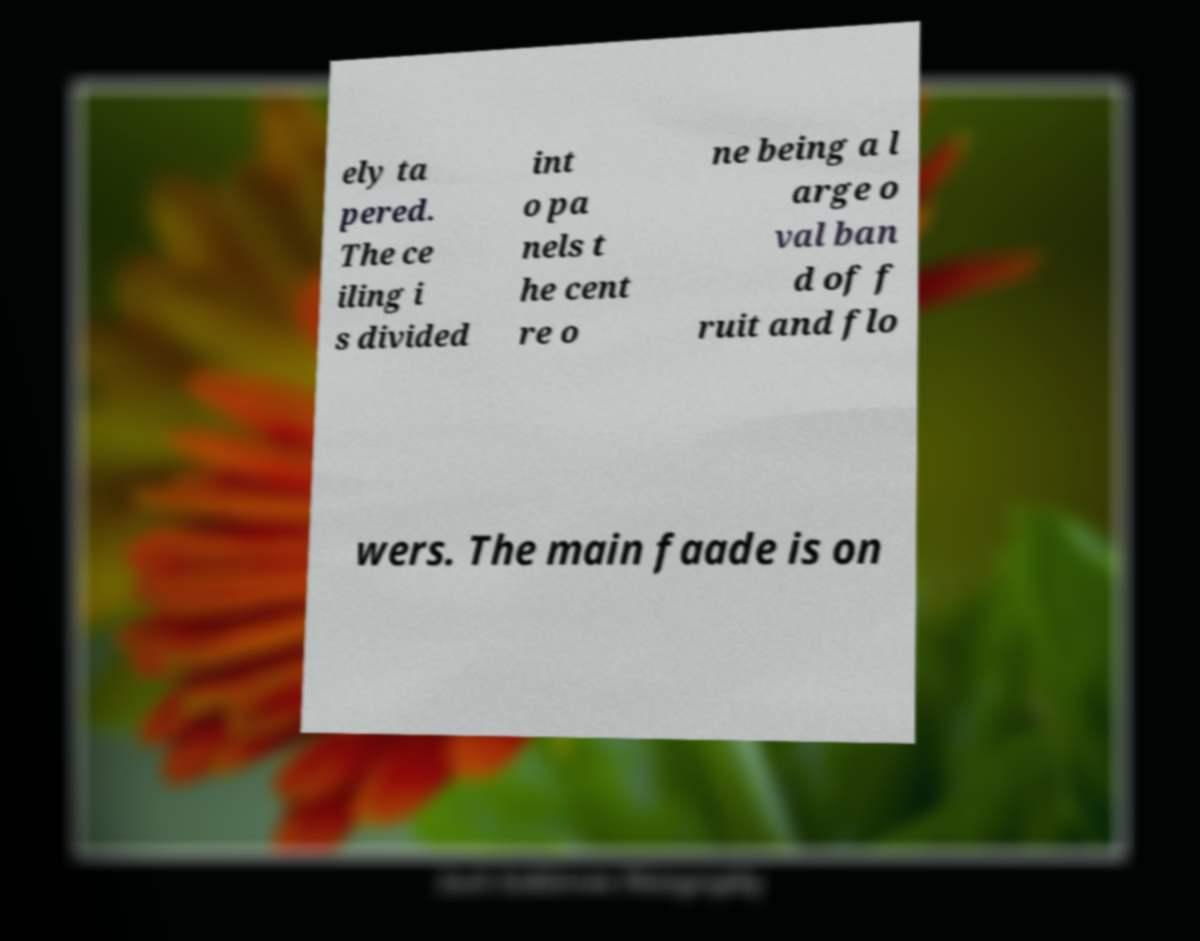Could you assist in decoding the text presented in this image and type it out clearly? ely ta pered. The ce iling i s divided int o pa nels t he cent re o ne being a l arge o val ban d of f ruit and flo wers. The main faade is on 